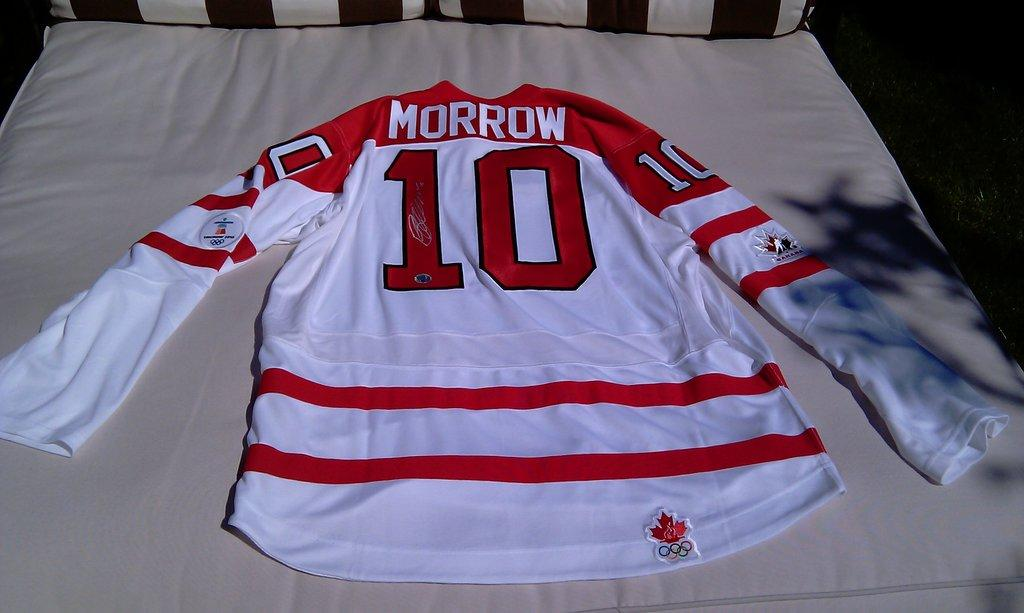<image>
Share a concise interpretation of the image provided. A sports jersey red and whit with the number 10 and name Morrow written on it. 